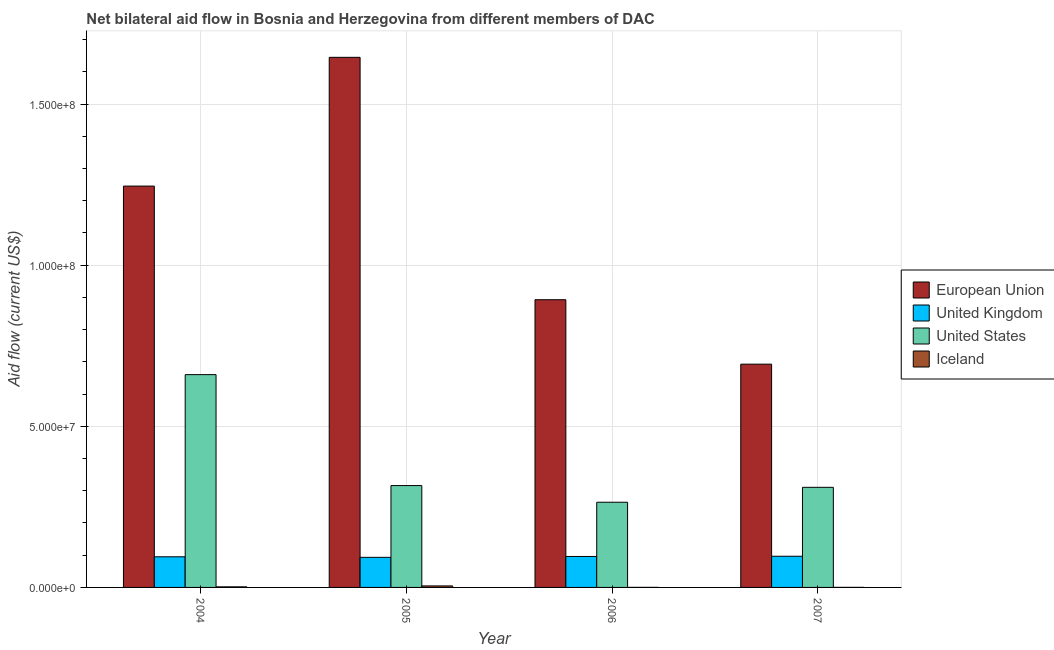How many different coloured bars are there?
Your response must be concise. 4. How many bars are there on the 1st tick from the left?
Your answer should be very brief. 4. How many bars are there on the 3rd tick from the right?
Your response must be concise. 4. What is the amount of aid given by us in 2004?
Offer a terse response. 6.60e+07. Across all years, what is the maximum amount of aid given by iceland?
Your response must be concise. 4.70e+05. Across all years, what is the minimum amount of aid given by iceland?
Your response must be concise. 2.00e+04. In which year was the amount of aid given by iceland maximum?
Offer a very short reply. 2005. In which year was the amount of aid given by iceland minimum?
Your answer should be compact. 2006. What is the total amount of aid given by eu in the graph?
Offer a very short reply. 4.48e+08. What is the difference between the amount of aid given by iceland in 2004 and that in 2006?
Your response must be concise. 1.60e+05. What is the difference between the amount of aid given by eu in 2005 and the amount of aid given by uk in 2004?
Offer a terse response. 4.00e+07. What is the average amount of aid given by uk per year?
Your answer should be compact. 9.54e+06. In the year 2007, what is the difference between the amount of aid given by uk and amount of aid given by iceland?
Your response must be concise. 0. What is the ratio of the amount of aid given by uk in 2004 to that in 2006?
Make the answer very short. 0.99. Is the amount of aid given by us in 2004 less than that in 2006?
Ensure brevity in your answer.  No. Is the difference between the amount of aid given by us in 2004 and 2006 greater than the difference between the amount of aid given by uk in 2004 and 2006?
Provide a short and direct response. No. What is the difference between the highest and the second highest amount of aid given by eu?
Offer a very short reply. 4.00e+07. What is the difference between the highest and the lowest amount of aid given by iceland?
Your answer should be very brief. 4.50e+05. How many bars are there?
Give a very brief answer. 16. Where does the legend appear in the graph?
Provide a succinct answer. Center right. How many legend labels are there?
Keep it short and to the point. 4. How are the legend labels stacked?
Offer a terse response. Vertical. What is the title of the graph?
Your answer should be compact. Net bilateral aid flow in Bosnia and Herzegovina from different members of DAC. Does "Labor Taxes" appear as one of the legend labels in the graph?
Provide a short and direct response. No. What is the label or title of the X-axis?
Offer a very short reply. Year. What is the Aid flow (current US$) in European Union in 2004?
Offer a terse response. 1.25e+08. What is the Aid flow (current US$) of United Kingdom in 2004?
Provide a short and direct response. 9.51e+06. What is the Aid flow (current US$) in United States in 2004?
Keep it short and to the point. 6.60e+07. What is the Aid flow (current US$) of Iceland in 2004?
Provide a short and direct response. 1.80e+05. What is the Aid flow (current US$) of European Union in 2005?
Your response must be concise. 1.65e+08. What is the Aid flow (current US$) in United Kingdom in 2005?
Your answer should be very brief. 9.34e+06. What is the Aid flow (current US$) in United States in 2005?
Offer a terse response. 3.16e+07. What is the Aid flow (current US$) in Iceland in 2005?
Ensure brevity in your answer.  4.70e+05. What is the Aid flow (current US$) of European Union in 2006?
Your answer should be very brief. 8.93e+07. What is the Aid flow (current US$) in United Kingdom in 2006?
Ensure brevity in your answer.  9.61e+06. What is the Aid flow (current US$) in United States in 2006?
Your answer should be compact. 2.64e+07. What is the Aid flow (current US$) of Iceland in 2006?
Provide a short and direct response. 2.00e+04. What is the Aid flow (current US$) in European Union in 2007?
Your answer should be compact. 6.93e+07. What is the Aid flow (current US$) of United Kingdom in 2007?
Ensure brevity in your answer.  9.68e+06. What is the Aid flow (current US$) of United States in 2007?
Your response must be concise. 3.11e+07. Across all years, what is the maximum Aid flow (current US$) of European Union?
Offer a terse response. 1.65e+08. Across all years, what is the maximum Aid flow (current US$) of United Kingdom?
Offer a terse response. 9.68e+06. Across all years, what is the maximum Aid flow (current US$) of United States?
Offer a very short reply. 6.60e+07. Across all years, what is the maximum Aid flow (current US$) of Iceland?
Your answer should be very brief. 4.70e+05. Across all years, what is the minimum Aid flow (current US$) in European Union?
Your response must be concise. 6.93e+07. Across all years, what is the minimum Aid flow (current US$) of United Kingdom?
Your response must be concise. 9.34e+06. Across all years, what is the minimum Aid flow (current US$) in United States?
Make the answer very short. 2.64e+07. Across all years, what is the minimum Aid flow (current US$) in Iceland?
Give a very brief answer. 2.00e+04. What is the total Aid flow (current US$) of European Union in the graph?
Offer a very short reply. 4.48e+08. What is the total Aid flow (current US$) of United Kingdom in the graph?
Your response must be concise. 3.81e+07. What is the total Aid flow (current US$) in United States in the graph?
Provide a succinct answer. 1.55e+08. What is the total Aid flow (current US$) in Iceland in the graph?
Your answer should be very brief. 6.90e+05. What is the difference between the Aid flow (current US$) of European Union in 2004 and that in 2005?
Keep it short and to the point. -4.00e+07. What is the difference between the Aid flow (current US$) of United Kingdom in 2004 and that in 2005?
Make the answer very short. 1.70e+05. What is the difference between the Aid flow (current US$) in United States in 2004 and that in 2005?
Provide a succinct answer. 3.44e+07. What is the difference between the Aid flow (current US$) in European Union in 2004 and that in 2006?
Your answer should be compact. 3.53e+07. What is the difference between the Aid flow (current US$) in United Kingdom in 2004 and that in 2006?
Give a very brief answer. -1.00e+05. What is the difference between the Aid flow (current US$) in United States in 2004 and that in 2006?
Keep it short and to the point. 3.96e+07. What is the difference between the Aid flow (current US$) of Iceland in 2004 and that in 2006?
Your answer should be very brief. 1.60e+05. What is the difference between the Aid flow (current US$) of European Union in 2004 and that in 2007?
Ensure brevity in your answer.  5.53e+07. What is the difference between the Aid flow (current US$) of United States in 2004 and that in 2007?
Give a very brief answer. 3.50e+07. What is the difference between the Aid flow (current US$) of Iceland in 2004 and that in 2007?
Provide a succinct answer. 1.60e+05. What is the difference between the Aid flow (current US$) of European Union in 2005 and that in 2006?
Provide a succinct answer. 7.52e+07. What is the difference between the Aid flow (current US$) of United States in 2005 and that in 2006?
Make the answer very short. 5.17e+06. What is the difference between the Aid flow (current US$) in European Union in 2005 and that in 2007?
Offer a very short reply. 9.52e+07. What is the difference between the Aid flow (current US$) in United States in 2005 and that in 2007?
Offer a terse response. 5.40e+05. What is the difference between the Aid flow (current US$) in European Union in 2006 and that in 2007?
Offer a terse response. 2.00e+07. What is the difference between the Aid flow (current US$) in United States in 2006 and that in 2007?
Provide a short and direct response. -4.63e+06. What is the difference between the Aid flow (current US$) in Iceland in 2006 and that in 2007?
Ensure brevity in your answer.  0. What is the difference between the Aid flow (current US$) in European Union in 2004 and the Aid flow (current US$) in United Kingdom in 2005?
Your response must be concise. 1.15e+08. What is the difference between the Aid flow (current US$) of European Union in 2004 and the Aid flow (current US$) of United States in 2005?
Offer a very short reply. 9.30e+07. What is the difference between the Aid flow (current US$) of European Union in 2004 and the Aid flow (current US$) of Iceland in 2005?
Give a very brief answer. 1.24e+08. What is the difference between the Aid flow (current US$) in United Kingdom in 2004 and the Aid flow (current US$) in United States in 2005?
Offer a terse response. -2.21e+07. What is the difference between the Aid flow (current US$) in United Kingdom in 2004 and the Aid flow (current US$) in Iceland in 2005?
Make the answer very short. 9.04e+06. What is the difference between the Aid flow (current US$) in United States in 2004 and the Aid flow (current US$) in Iceland in 2005?
Give a very brief answer. 6.56e+07. What is the difference between the Aid flow (current US$) in European Union in 2004 and the Aid flow (current US$) in United Kingdom in 2006?
Your answer should be very brief. 1.15e+08. What is the difference between the Aid flow (current US$) in European Union in 2004 and the Aid flow (current US$) in United States in 2006?
Your answer should be very brief. 9.81e+07. What is the difference between the Aid flow (current US$) in European Union in 2004 and the Aid flow (current US$) in Iceland in 2006?
Offer a very short reply. 1.25e+08. What is the difference between the Aid flow (current US$) of United Kingdom in 2004 and the Aid flow (current US$) of United States in 2006?
Offer a very short reply. -1.69e+07. What is the difference between the Aid flow (current US$) in United Kingdom in 2004 and the Aid flow (current US$) in Iceland in 2006?
Your answer should be compact. 9.49e+06. What is the difference between the Aid flow (current US$) in United States in 2004 and the Aid flow (current US$) in Iceland in 2006?
Provide a succinct answer. 6.60e+07. What is the difference between the Aid flow (current US$) in European Union in 2004 and the Aid flow (current US$) in United Kingdom in 2007?
Your answer should be very brief. 1.15e+08. What is the difference between the Aid flow (current US$) of European Union in 2004 and the Aid flow (current US$) of United States in 2007?
Give a very brief answer. 9.35e+07. What is the difference between the Aid flow (current US$) in European Union in 2004 and the Aid flow (current US$) in Iceland in 2007?
Make the answer very short. 1.25e+08. What is the difference between the Aid flow (current US$) of United Kingdom in 2004 and the Aid flow (current US$) of United States in 2007?
Your answer should be compact. -2.16e+07. What is the difference between the Aid flow (current US$) in United Kingdom in 2004 and the Aid flow (current US$) in Iceland in 2007?
Offer a terse response. 9.49e+06. What is the difference between the Aid flow (current US$) of United States in 2004 and the Aid flow (current US$) of Iceland in 2007?
Your answer should be very brief. 6.60e+07. What is the difference between the Aid flow (current US$) in European Union in 2005 and the Aid flow (current US$) in United Kingdom in 2006?
Keep it short and to the point. 1.55e+08. What is the difference between the Aid flow (current US$) of European Union in 2005 and the Aid flow (current US$) of United States in 2006?
Your answer should be very brief. 1.38e+08. What is the difference between the Aid flow (current US$) of European Union in 2005 and the Aid flow (current US$) of Iceland in 2006?
Your answer should be compact. 1.64e+08. What is the difference between the Aid flow (current US$) of United Kingdom in 2005 and the Aid flow (current US$) of United States in 2006?
Your answer should be very brief. -1.71e+07. What is the difference between the Aid flow (current US$) in United Kingdom in 2005 and the Aid flow (current US$) in Iceland in 2006?
Offer a terse response. 9.32e+06. What is the difference between the Aid flow (current US$) in United States in 2005 and the Aid flow (current US$) in Iceland in 2006?
Your answer should be very brief. 3.16e+07. What is the difference between the Aid flow (current US$) of European Union in 2005 and the Aid flow (current US$) of United Kingdom in 2007?
Offer a very short reply. 1.55e+08. What is the difference between the Aid flow (current US$) of European Union in 2005 and the Aid flow (current US$) of United States in 2007?
Provide a succinct answer. 1.33e+08. What is the difference between the Aid flow (current US$) in European Union in 2005 and the Aid flow (current US$) in Iceland in 2007?
Provide a succinct answer. 1.64e+08. What is the difference between the Aid flow (current US$) in United Kingdom in 2005 and the Aid flow (current US$) in United States in 2007?
Offer a very short reply. -2.17e+07. What is the difference between the Aid flow (current US$) of United Kingdom in 2005 and the Aid flow (current US$) of Iceland in 2007?
Offer a terse response. 9.32e+06. What is the difference between the Aid flow (current US$) in United States in 2005 and the Aid flow (current US$) in Iceland in 2007?
Keep it short and to the point. 3.16e+07. What is the difference between the Aid flow (current US$) of European Union in 2006 and the Aid flow (current US$) of United Kingdom in 2007?
Your response must be concise. 7.96e+07. What is the difference between the Aid flow (current US$) of European Union in 2006 and the Aid flow (current US$) of United States in 2007?
Offer a terse response. 5.82e+07. What is the difference between the Aid flow (current US$) of European Union in 2006 and the Aid flow (current US$) of Iceland in 2007?
Give a very brief answer. 8.93e+07. What is the difference between the Aid flow (current US$) in United Kingdom in 2006 and the Aid flow (current US$) in United States in 2007?
Provide a succinct answer. -2.15e+07. What is the difference between the Aid flow (current US$) in United Kingdom in 2006 and the Aid flow (current US$) in Iceland in 2007?
Provide a succinct answer. 9.59e+06. What is the difference between the Aid flow (current US$) of United States in 2006 and the Aid flow (current US$) of Iceland in 2007?
Provide a short and direct response. 2.64e+07. What is the average Aid flow (current US$) of European Union per year?
Make the answer very short. 1.12e+08. What is the average Aid flow (current US$) of United Kingdom per year?
Keep it short and to the point. 9.54e+06. What is the average Aid flow (current US$) in United States per year?
Provide a succinct answer. 3.88e+07. What is the average Aid flow (current US$) in Iceland per year?
Offer a terse response. 1.72e+05. In the year 2004, what is the difference between the Aid flow (current US$) in European Union and Aid flow (current US$) in United Kingdom?
Keep it short and to the point. 1.15e+08. In the year 2004, what is the difference between the Aid flow (current US$) of European Union and Aid flow (current US$) of United States?
Provide a short and direct response. 5.85e+07. In the year 2004, what is the difference between the Aid flow (current US$) in European Union and Aid flow (current US$) in Iceland?
Offer a very short reply. 1.24e+08. In the year 2004, what is the difference between the Aid flow (current US$) in United Kingdom and Aid flow (current US$) in United States?
Make the answer very short. -5.65e+07. In the year 2004, what is the difference between the Aid flow (current US$) in United Kingdom and Aid flow (current US$) in Iceland?
Offer a terse response. 9.33e+06. In the year 2004, what is the difference between the Aid flow (current US$) in United States and Aid flow (current US$) in Iceland?
Offer a very short reply. 6.59e+07. In the year 2005, what is the difference between the Aid flow (current US$) in European Union and Aid flow (current US$) in United Kingdom?
Make the answer very short. 1.55e+08. In the year 2005, what is the difference between the Aid flow (current US$) of European Union and Aid flow (current US$) of United States?
Your response must be concise. 1.33e+08. In the year 2005, what is the difference between the Aid flow (current US$) in European Union and Aid flow (current US$) in Iceland?
Your answer should be compact. 1.64e+08. In the year 2005, what is the difference between the Aid flow (current US$) in United Kingdom and Aid flow (current US$) in United States?
Give a very brief answer. -2.23e+07. In the year 2005, what is the difference between the Aid flow (current US$) of United Kingdom and Aid flow (current US$) of Iceland?
Make the answer very short. 8.87e+06. In the year 2005, what is the difference between the Aid flow (current US$) of United States and Aid flow (current US$) of Iceland?
Give a very brief answer. 3.11e+07. In the year 2006, what is the difference between the Aid flow (current US$) in European Union and Aid flow (current US$) in United Kingdom?
Ensure brevity in your answer.  7.97e+07. In the year 2006, what is the difference between the Aid flow (current US$) of European Union and Aid flow (current US$) of United States?
Keep it short and to the point. 6.28e+07. In the year 2006, what is the difference between the Aid flow (current US$) in European Union and Aid flow (current US$) in Iceland?
Offer a very short reply. 8.93e+07. In the year 2006, what is the difference between the Aid flow (current US$) of United Kingdom and Aid flow (current US$) of United States?
Offer a very short reply. -1.68e+07. In the year 2006, what is the difference between the Aid flow (current US$) in United Kingdom and Aid flow (current US$) in Iceland?
Your response must be concise. 9.59e+06. In the year 2006, what is the difference between the Aid flow (current US$) of United States and Aid flow (current US$) of Iceland?
Keep it short and to the point. 2.64e+07. In the year 2007, what is the difference between the Aid flow (current US$) in European Union and Aid flow (current US$) in United Kingdom?
Make the answer very short. 5.96e+07. In the year 2007, what is the difference between the Aid flow (current US$) in European Union and Aid flow (current US$) in United States?
Offer a terse response. 3.82e+07. In the year 2007, what is the difference between the Aid flow (current US$) of European Union and Aid flow (current US$) of Iceland?
Your response must be concise. 6.93e+07. In the year 2007, what is the difference between the Aid flow (current US$) in United Kingdom and Aid flow (current US$) in United States?
Keep it short and to the point. -2.14e+07. In the year 2007, what is the difference between the Aid flow (current US$) in United Kingdom and Aid flow (current US$) in Iceland?
Give a very brief answer. 9.66e+06. In the year 2007, what is the difference between the Aid flow (current US$) in United States and Aid flow (current US$) in Iceland?
Your answer should be very brief. 3.10e+07. What is the ratio of the Aid flow (current US$) of European Union in 2004 to that in 2005?
Your answer should be very brief. 0.76. What is the ratio of the Aid flow (current US$) of United Kingdom in 2004 to that in 2005?
Offer a very short reply. 1.02. What is the ratio of the Aid flow (current US$) of United States in 2004 to that in 2005?
Your response must be concise. 2.09. What is the ratio of the Aid flow (current US$) of Iceland in 2004 to that in 2005?
Make the answer very short. 0.38. What is the ratio of the Aid flow (current US$) of European Union in 2004 to that in 2006?
Make the answer very short. 1.4. What is the ratio of the Aid flow (current US$) in United States in 2004 to that in 2006?
Offer a terse response. 2.5. What is the ratio of the Aid flow (current US$) of European Union in 2004 to that in 2007?
Provide a succinct answer. 1.8. What is the ratio of the Aid flow (current US$) in United Kingdom in 2004 to that in 2007?
Provide a succinct answer. 0.98. What is the ratio of the Aid flow (current US$) in United States in 2004 to that in 2007?
Offer a terse response. 2.13. What is the ratio of the Aid flow (current US$) in Iceland in 2004 to that in 2007?
Provide a short and direct response. 9. What is the ratio of the Aid flow (current US$) in European Union in 2005 to that in 2006?
Ensure brevity in your answer.  1.84. What is the ratio of the Aid flow (current US$) in United Kingdom in 2005 to that in 2006?
Offer a terse response. 0.97. What is the ratio of the Aid flow (current US$) in United States in 2005 to that in 2006?
Give a very brief answer. 1.2. What is the ratio of the Aid flow (current US$) of Iceland in 2005 to that in 2006?
Give a very brief answer. 23.5. What is the ratio of the Aid flow (current US$) in European Union in 2005 to that in 2007?
Give a very brief answer. 2.37. What is the ratio of the Aid flow (current US$) of United Kingdom in 2005 to that in 2007?
Your answer should be very brief. 0.96. What is the ratio of the Aid flow (current US$) of United States in 2005 to that in 2007?
Your answer should be compact. 1.02. What is the ratio of the Aid flow (current US$) of Iceland in 2005 to that in 2007?
Offer a terse response. 23.5. What is the ratio of the Aid flow (current US$) in European Union in 2006 to that in 2007?
Keep it short and to the point. 1.29. What is the ratio of the Aid flow (current US$) in United Kingdom in 2006 to that in 2007?
Provide a short and direct response. 0.99. What is the ratio of the Aid flow (current US$) of United States in 2006 to that in 2007?
Give a very brief answer. 0.85. What is the ratio of the Aid flow (current US$) in Iceland in 2006 to that in 2007?
Offer a very short reply. 1. What is the difference between the highest and the second highest Aid flow (current US$) in European Union?
Make the answer very short. 4.00e+07. What is the difference between the highest and the second highest Aid flow (current US$) of United Kingdom?
Your answer should be very brief. 7.00e+04. What is the difference between the highest and the second highest Aid flow (current US$) in United States?
Provide a short and direct response. 3.44e+07. What is the difference between the highest and the second highest Aid flow (current US$) of Iceland?
Offer a very short reply. 2.90e+05. What is the difference between the highest and the lowest Aid flow (current US$) of European Union?
Ensure brevity in your answer.  9.52e+07. What is the difference between the highest and the lowest Aid flow (current US$) in United States?
Your answer should be very brief. 3.96e+07. What is the difference between the highest and the lowest Aid flow (current US$) in Iceland?
Give a very brief answer. 4.50e+05. 